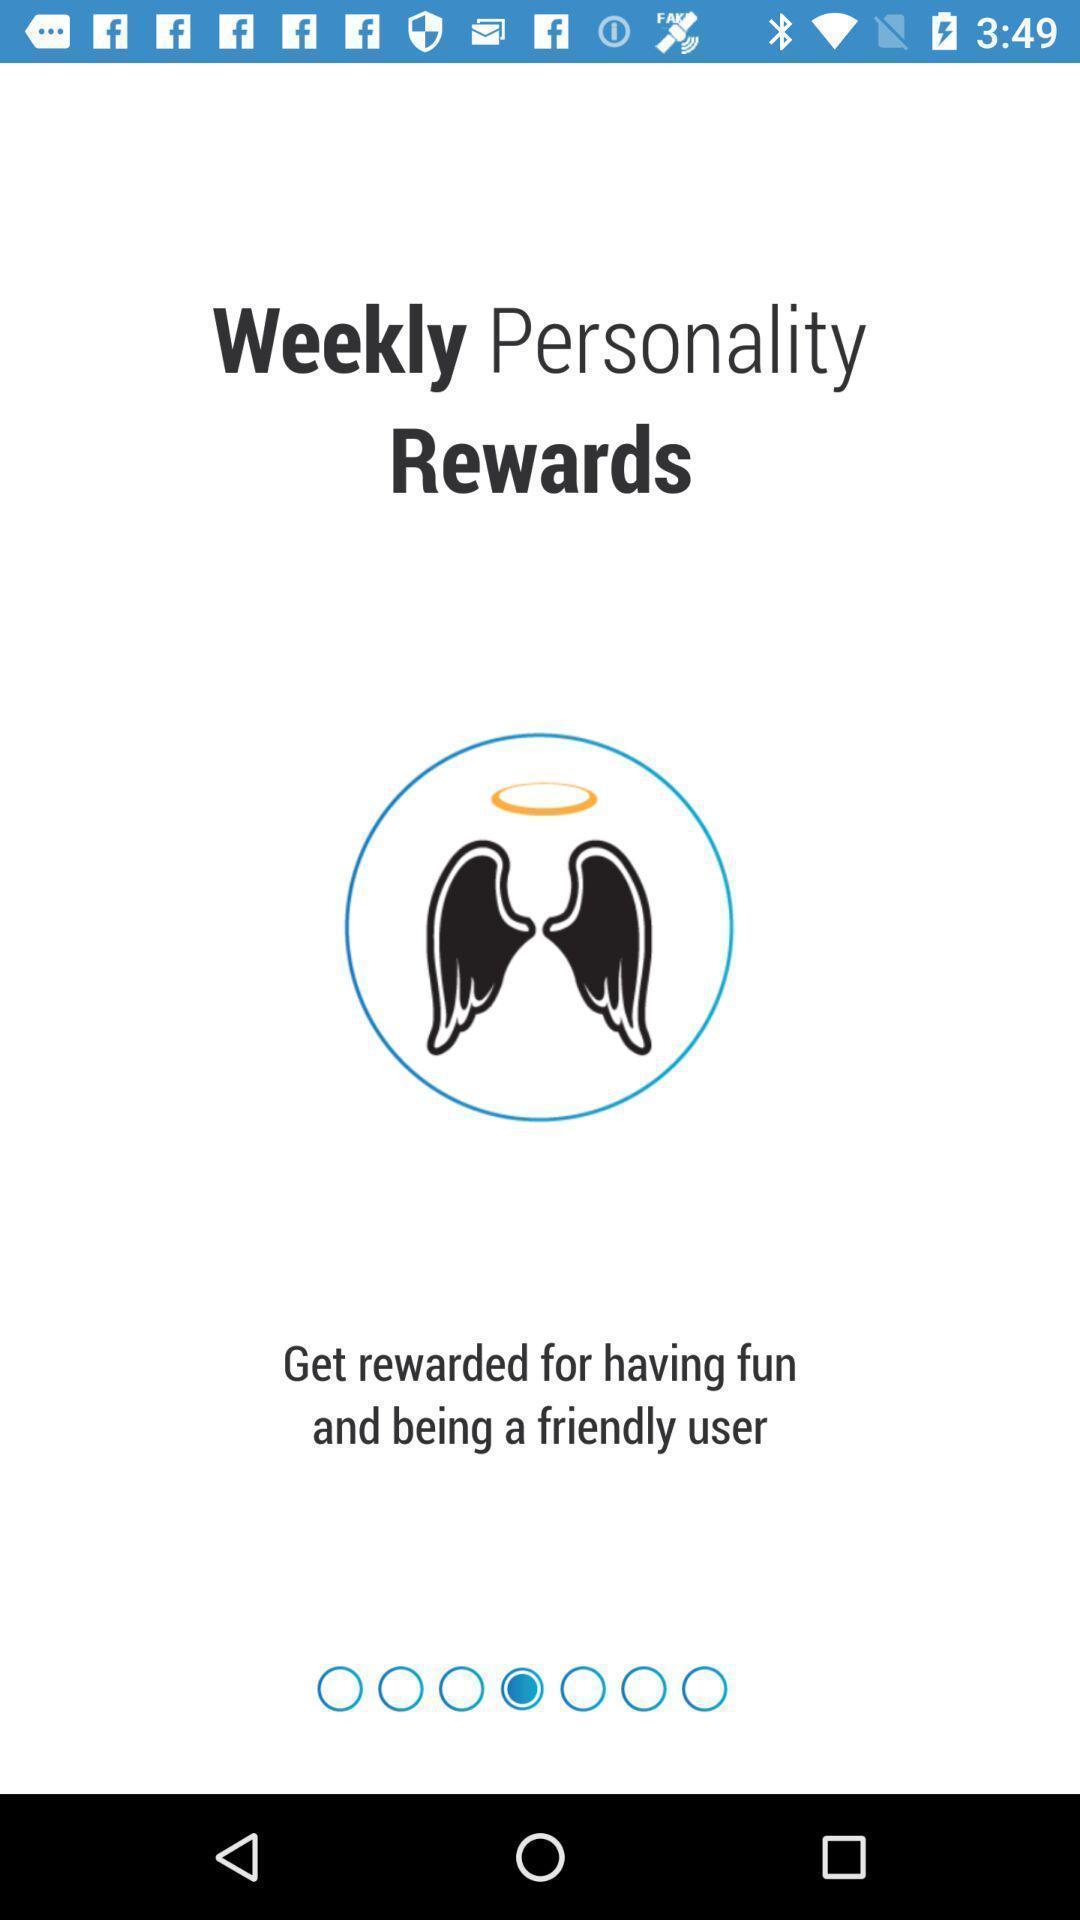Describe this image in words. Page showing home page. 